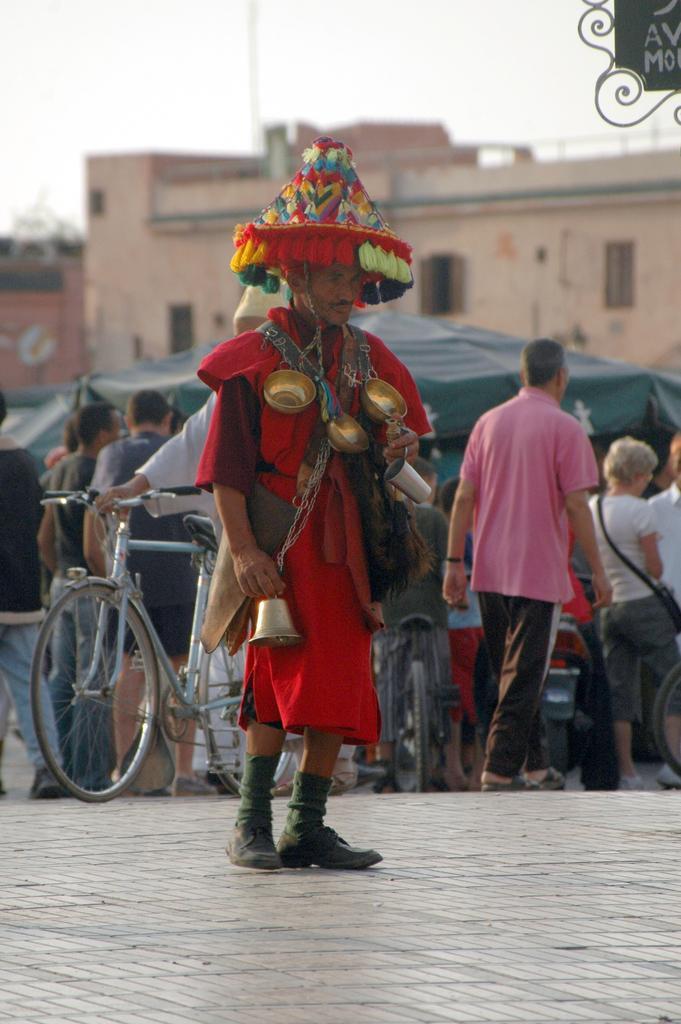Can you describe this image briefly? In this picture we can see a man standing on the ground, bell, cap, bicycles and a group of people walking on the road, tents, buildings with windows and in the background we can see the sky. 